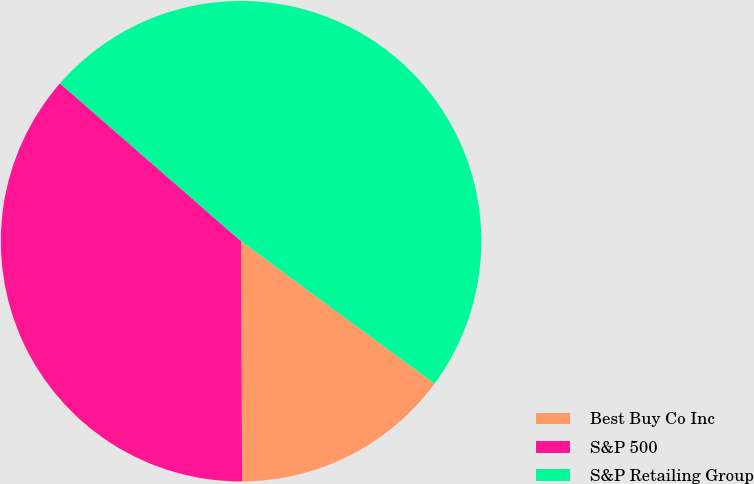<chart> <loc_0><loc_0><loc_500><loc_500><pie_chart><fcel>Best Buy Co Inc<fcel>S&P 500<fcel>S&P Retailing Group<nl><fcel>14.83%<fcel>36.48%<fcel>48.69%<nl></chart> 